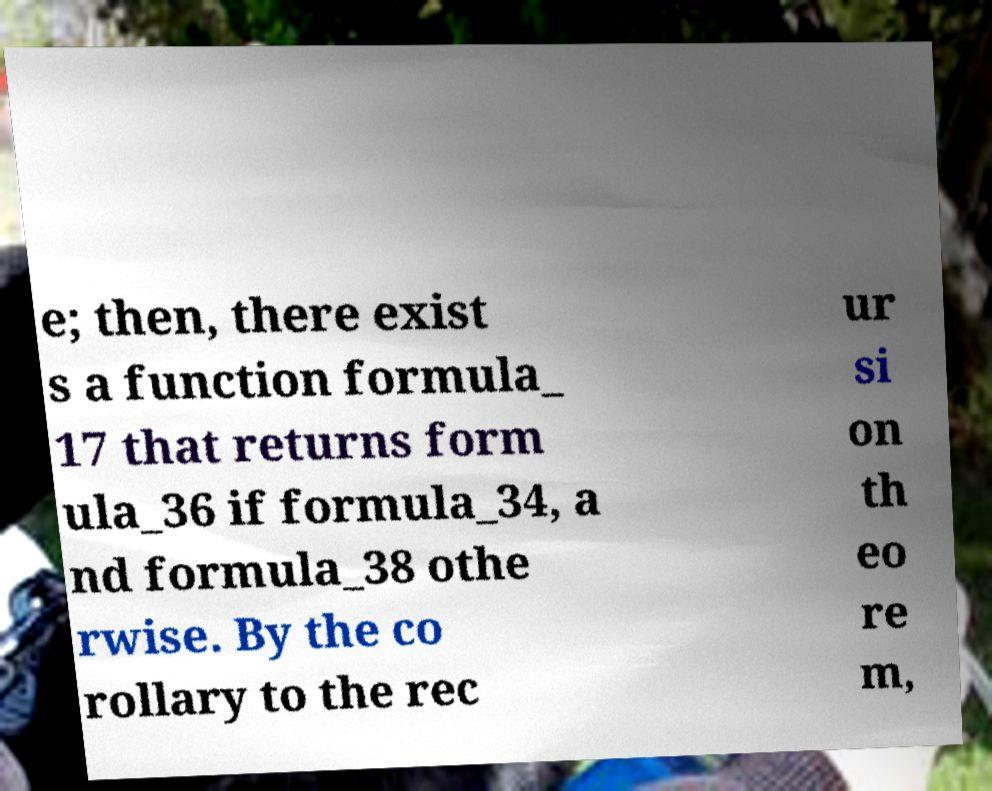There's text embedded in this image that I need extracted. Can you transcribe it verbatim? e; then, there exist s a function formula_ 17 that returns form ula_36 if formula_34, a nd formula_38 othe rwise. By the co rollary to the rec ur si on th eo re m, 